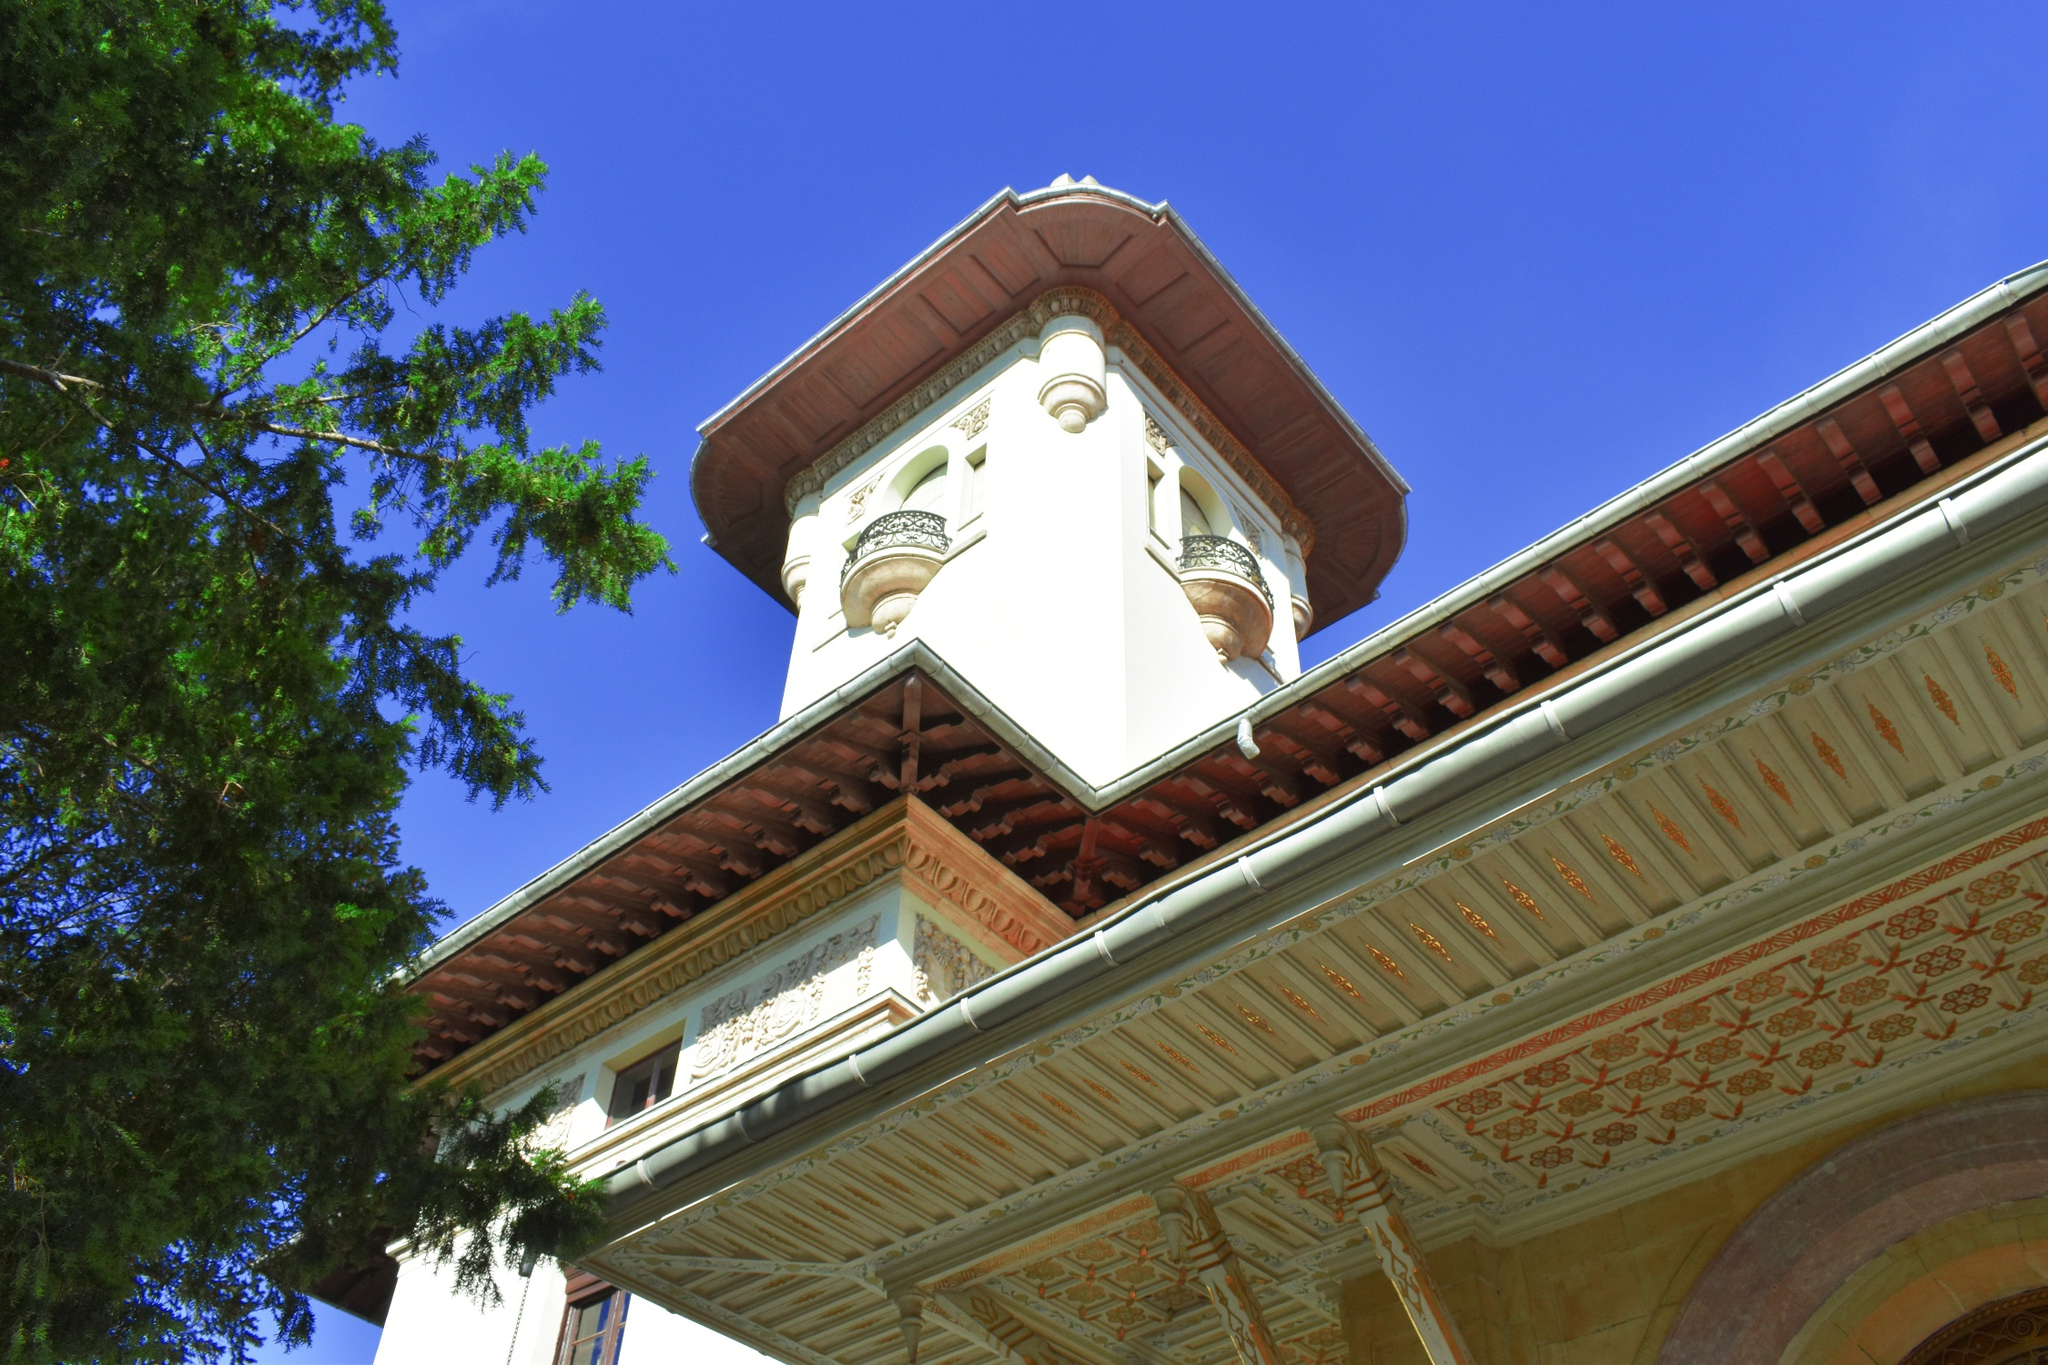You discover a hidden room in the tower. Describe what you find inside. Upon discovering a hidden room in the tower, you find yourself entering a space frozen in time. The room is bathed in a soft, golden light filtering through stained glass windows. The walls are adorned with aged tapestries, depicting scenes of historical significance and mythical legends. A grand, ornate chandelier hangs from the ceiling, its crystals sparkling like stars. In the center of the room stands an ancient wooden table, its surface covered in dust but beautifully crafted with intricate carvings. Shelves lined with old books and scrolls hint at forgotten knowledge and untold stories. Antique furniture, covered in elegant fabrics, adds to the room's mystique. An aura of mystery and history permeates the air, making you feel as if you've stepped into another era, uncovering secrets long kept within the tower's confines. Could this tower be part of a magical realm? Describe such a world. In a magical realm where this tower stands, the world is infused with enchantment and wonder. The tower itself is a beacon of mystical power, its walls glowing faintly with ancient runes that pulse with magic. The realm around it is a lush landscape of verdant forests, crystal-clear lakes, and rolling hills dotted with colorful, luminescent flora. The sky above shimmers with hues of purples and blues, as if dawn and dusk coexist in perfect harmony. Creatures of myth and legend roam freely – elves, fairies, and dragons coexist with humans in a harmonious balance. Floating islands drift lazily in the sky, connected by bridges of light. The air is filled with a sense of serenity and possibility, where spells weave reality and dreams manifest into tangible forms. In this world, the tower is both a sanctuary and a place of learning, where ancient wizards impart knowledge and young apprentices hone their magical abilities, ensuring that the magic of the realm flows continuously through time. 